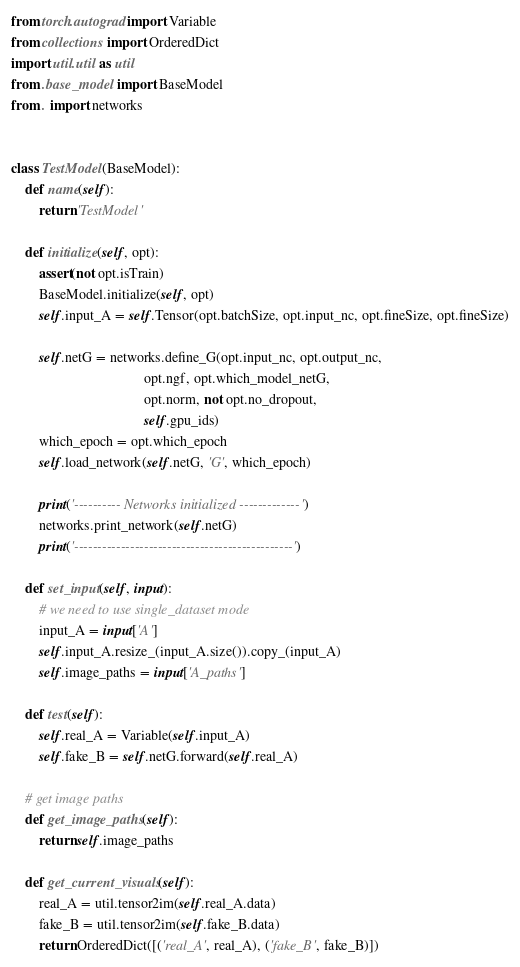<code> <loc_0><loc_0><loc_500><loc_500><_Python_>from torch.autograd import Variable
from collections import OrderedDict
import util.util as util
from .base_model import BaseModel
from . import networks


class TestModel(BaseModel):
    def name(self):
        return 'TestModel'

    def initialize(self, opt):
        assert(not opt.isTrain)
        BaseModel.initialize(self, opt)
        self.input_A = self.Tensor(opt.batchSize, opt.input_nc, opt.fineSize, opt.fineSize)

        self.netG = networks.define_G(opt.input_nc, opt.output_nc,
                                      opt.ngf, opt.which_model_netG,
                                      opt.norm, not opt.no_dropout,
                                      self.gpu_ids)
        which_epoch = opt.which_epoch
        self.load_network(self.netG, 'G', which_epoch)

        print('---------- Networks initialized -------------')
        networks.print_network(self.netG)
        print('-----------------------------------------------')

    def set_input(self, input):
        # we need to use single_dataset mode
        input_A = input['A']
        self.input_A.resize_(input_A.size()).copy_(input_A)
        self.image_paths = input['A_paths']

    def test(self):
        self.real_A = Variable(self.input_A)
        self.fake_B = self.netG.forward(self.real_A)

    # get image paths
    def get_image_paths(self):
        return self.image_paths

    def get_current_visuals(self):
        real_A = util.tensor2im(self.real_A.data)
        fake_B = util.tensor2im(self.fake_B.data)
        return OrderedDict([('real_A', real_A), ('fake_B', fake_B)])
</code> 